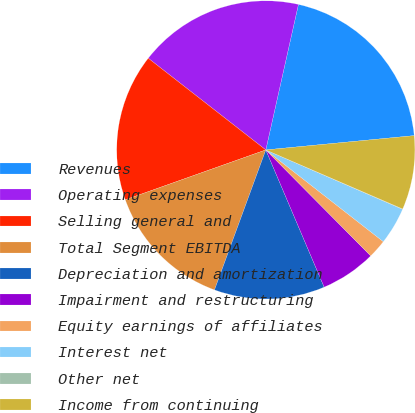Convert chart to OTSL. <chart><loc_0><loc_0><loc_500><loc_500><pie_chart><fcel>Revenues<fcel>Operating expenses<fcel>Selling general and<fcel>Total Segment EBITDA<fcel>Depreciation and amortization<fcel>Impairment and restructuring<fcel>Equity earnings of affiliates<fcel>Interest net<fcel>Other net<fcel>Income from continuing<nl><fcel>19.96%<fcel>17.97%<fcel>15.97%<fcel>13.98%<fcel>11.99%<fcel>6.02%<fcel>2.03%<fcel>4.03%<fcel>0.04%<fcel>8.01%<nl></chart> 